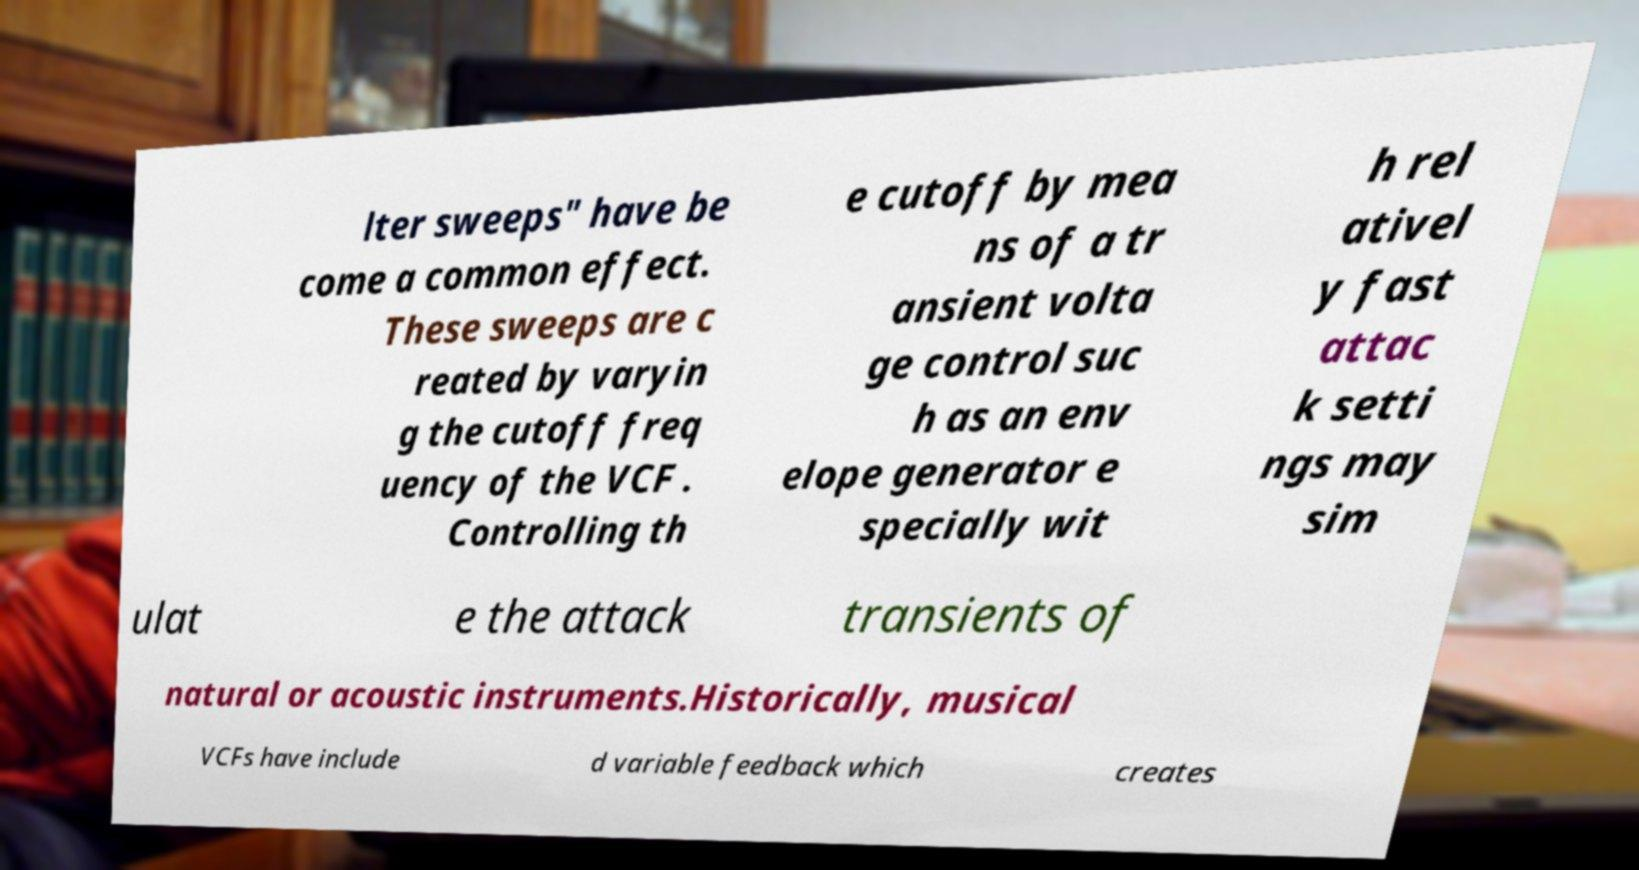Can you accurately transcribe the text from the provided image for me? lter sweeps" have be come a common effect. These sweeps are c reated by varyin g the cutoff freq uency of the VCF . Controlling th e cutoff by mea ns of a tr ansient volta ge control suc h as an env elope generator e specially wit h rel ativel y fast attac k setti ngs may sim ulat e the attack transients of natural or acoustic instruments.Historically, musical VCFs have include d variable feedback which creates 